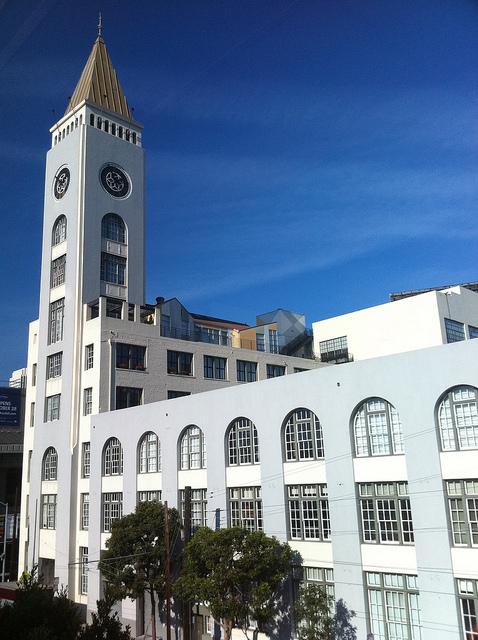Is there a clock in this picture?
Concise answer only. Yes. Is the color of the building the original paint color?
Give a very brief answer. No. What is the weather like?
Keep it brief. Sunny. Are there any trees in the photo?
Give a very brief answer. Yes. 